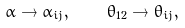Convert formula to latex. <formula><loc_0><loc_0><loc_500><loc_500>\alpha \rightarrow \alpha _ { i j } , \quad \theta _ { 1 2 } \rightarrow \theta _ { i j } ,</formula> 